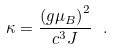<formula> <loc_0><loc_0><loc_500><loc_500>\kappa = \frac { { ( g \mu _ { B } ) } ^ { 2 } } { c ^ { 3 } J } \ .</formula> 